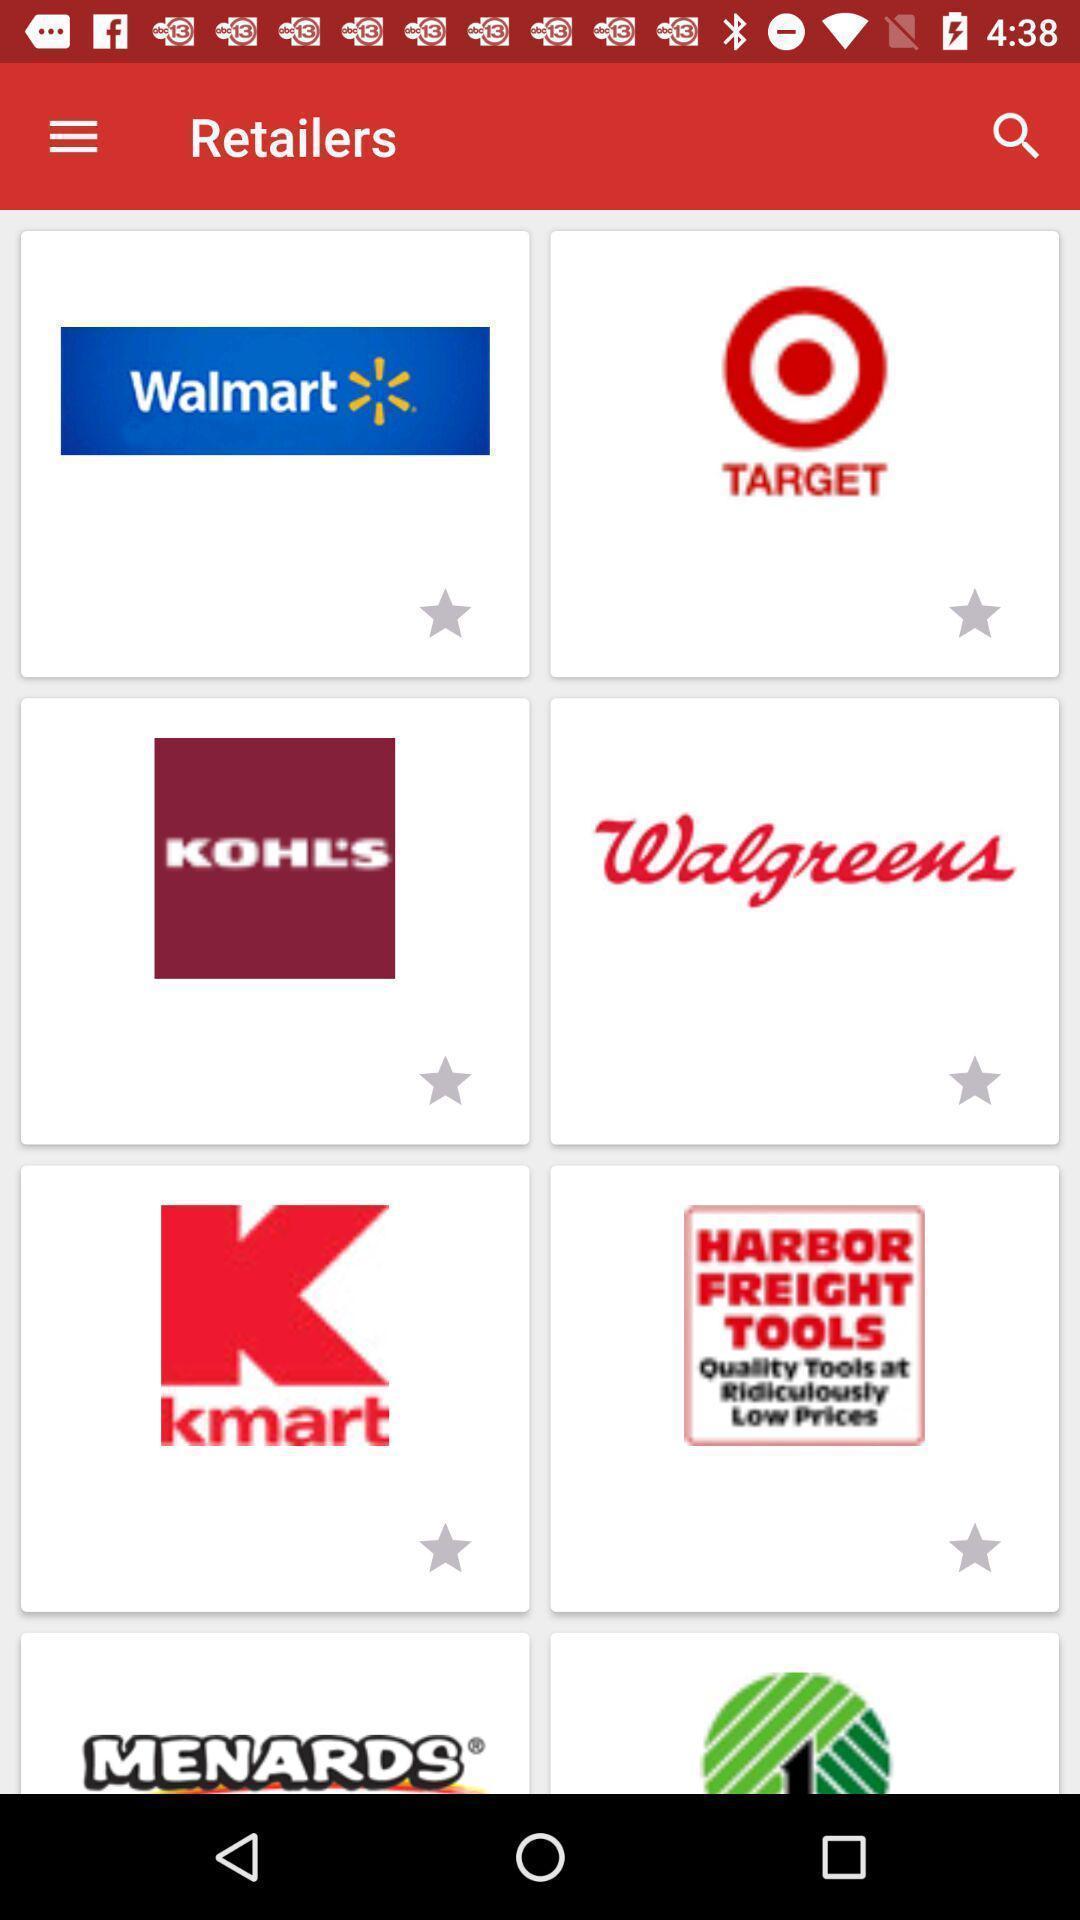What can you discern from this picture? Page displaying the multiple app. 